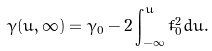<formula> <loc_0><loc_0><loc_500><loc_500>\gamma ( u , \infty ) = \gamma _ { 0 } - 2 \int _ { - \infty } ^ { u } \dot { f } _ { 0 } ^ { 2 } d u .</formula> 